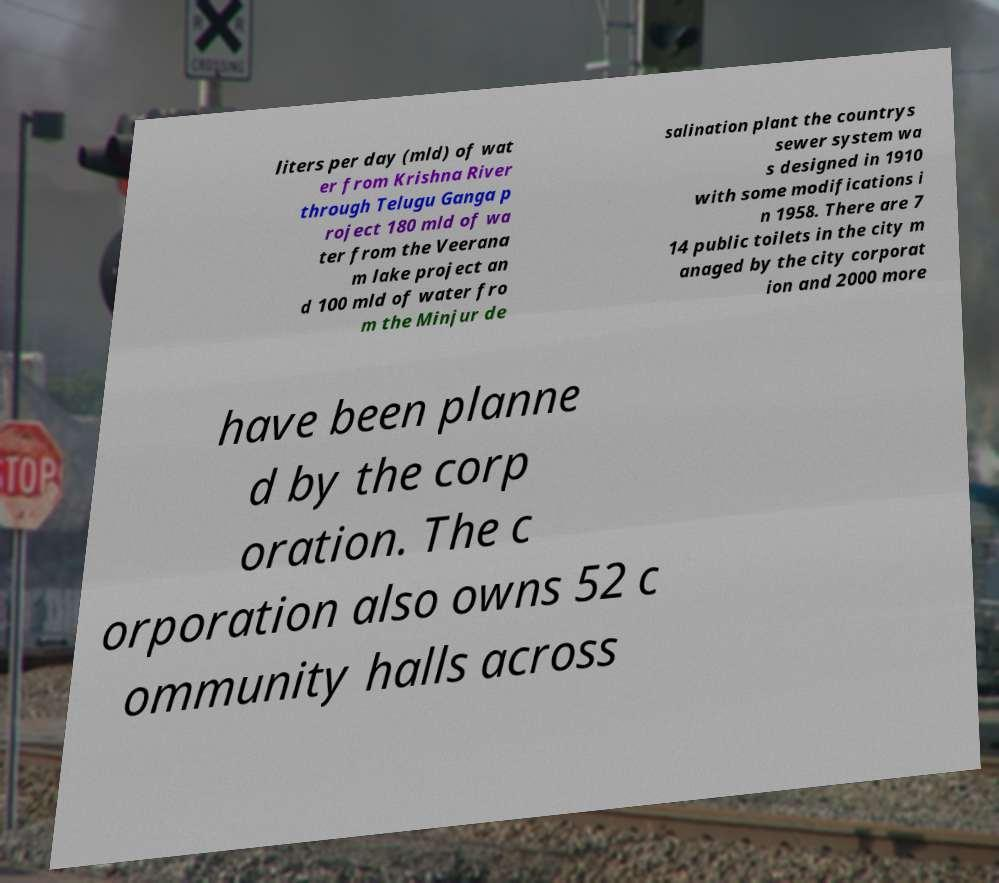Can you accurately transcribe the text from the provided image for me? liters per day (mld) of wat er from Krishna River through Telugu Ganga p roject 180 mld of wa ter from the Veerana m lake project an d 100 mld of water fro m the Minjur de salination plant the countrys sewer system wa s designed in 1910 with some modifications i n 1958. There are 7 14 public toilets in the city m anaged by the city corporat ion and 2000 more have been planne d by the corp oration. The c orporation also owns 52 c ommunity halls across 